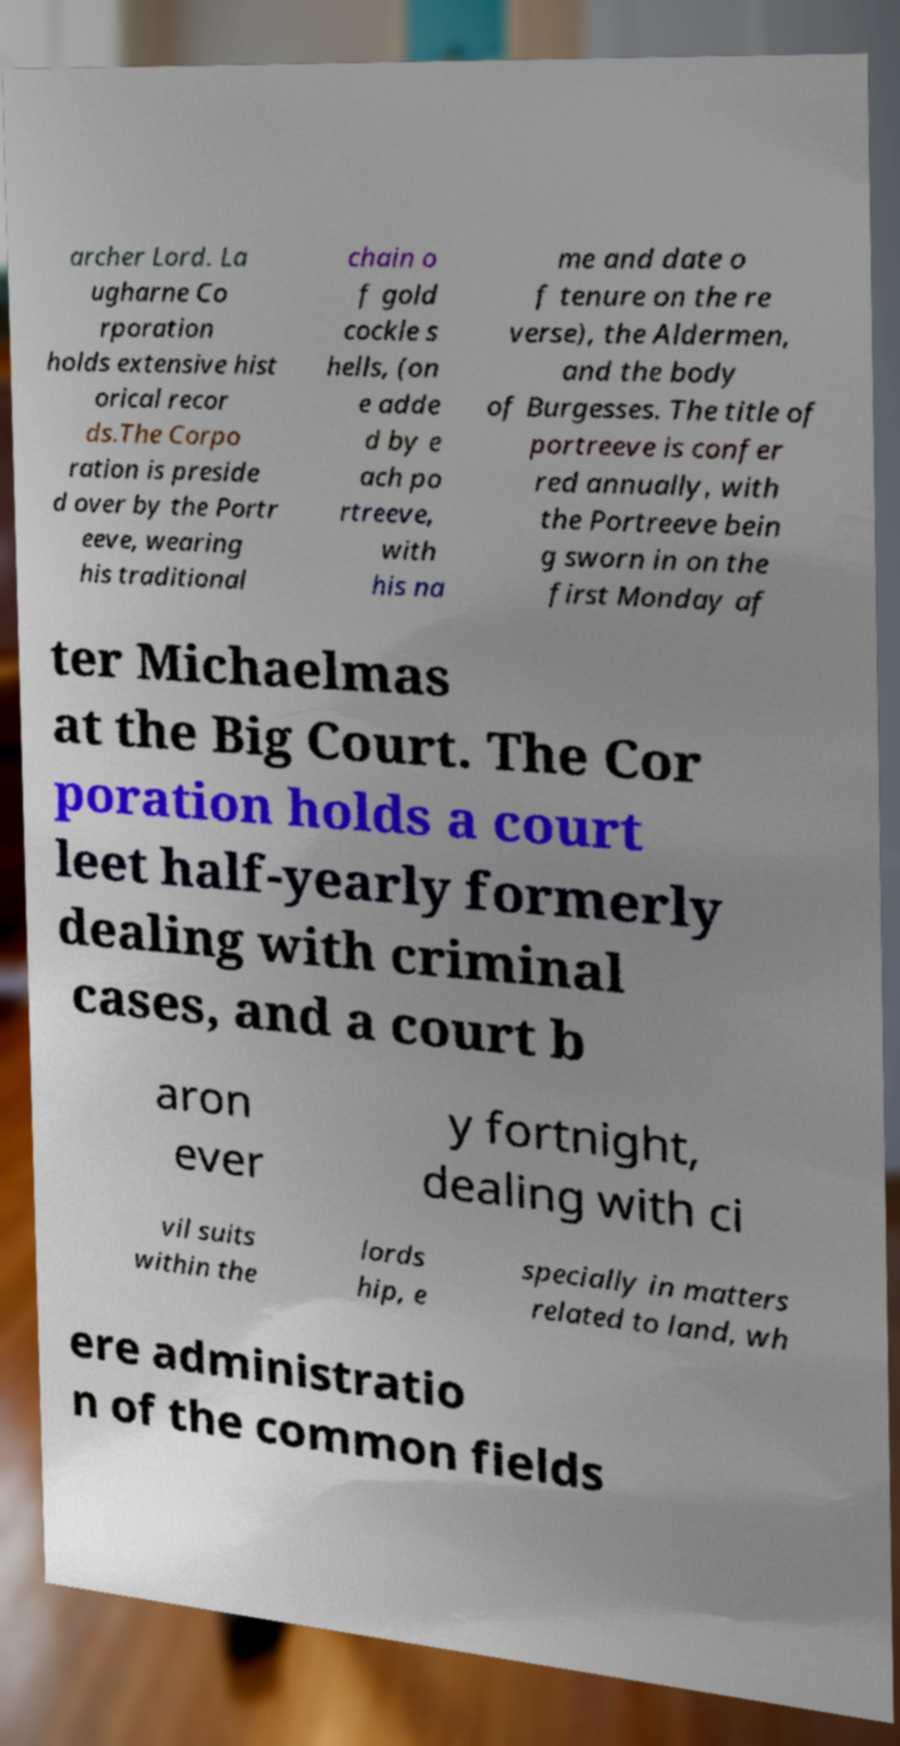What messages or text are displayed in this image? I need them in a readable, typed format. archer Lord. La ugharne Co rporation holds extensive hist orical recor ds.The Corpo ration is preside d over by the Portr eeve, wearing his traditional chain o f gold cockle s hells, (on e adde d by e ach po rtreeve, with his na me and date o f tenure on the re verse), the Aldermen, and the body of Burgesses. The title of portreeve is confer red annually, with the Portreeve bein g sworn in on the first Monday af ter Michaelmas at the Big Court. The Cor poration holds a court leet half-yearly formerly dealing with criminal cases, and a court b aron ever y fortnight, dealing with ci vil suits within the lords hip, e specially in matters related to land, wh ere administratio n of the common fields 